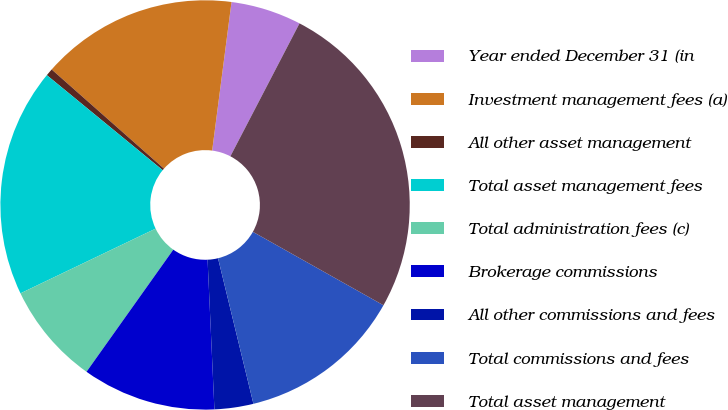Convert chart. <chart><loc_0><loc_0><loc_500><loc_500><pie_chart><fcel>Year ended December 31 (in<fcel>Investment management fees (a)<fcel>All other asset management<fcel>Total asset management fees<fcel>Total administration fees (c)<fcel>Brokerage commissions<fcel>All other commissions and fees<fcel>Total commissions and fees<fcel>Total asset management<nl><fcel>5.57%<fcel>15.55%<fcel>0.58%<fcel>18.04%<fcel>8.06%<fcel>10.56%<fcel>3.07%<fcel>13.05%<fcel>25.52%<nl></chart> 